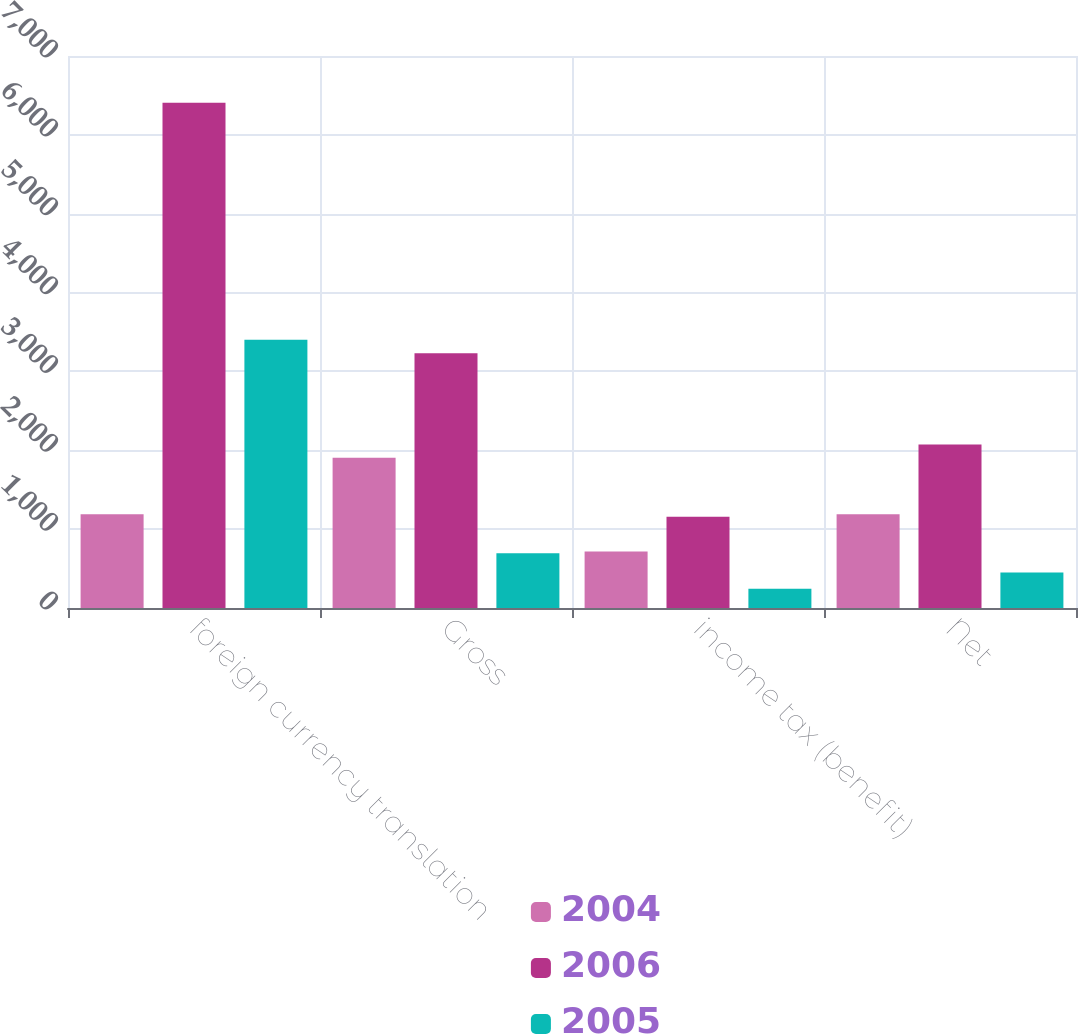Convert chart. <chart><loc_0><loc_0><loc_500><loc_500><stacked_bar_chart><ecel><fcel>foreign currency translation<fcel>Gross<fcel>income tax (benefit)<fcel>Net<nl><fcel>2004<fcel>1188<fcel>1905<fcel>717<fcel>1188<nl><fcel>2006<fcel>6407<fcel>3230<fcel>1157<fcel>2073<nl><fcel>2005<fcel>3402<fcel>694<fcel>243<fcel>451<nl></chart> 